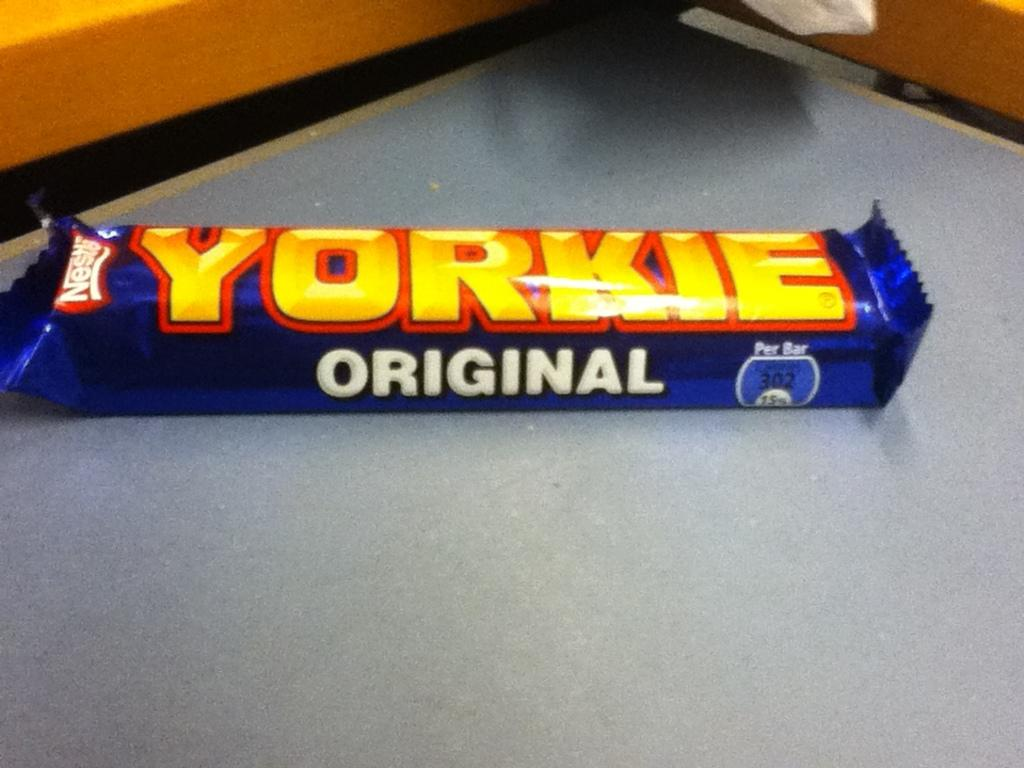Provide a one-sentence caption for the provided image. The candy bar Yorkie Original is made by Nestle. 